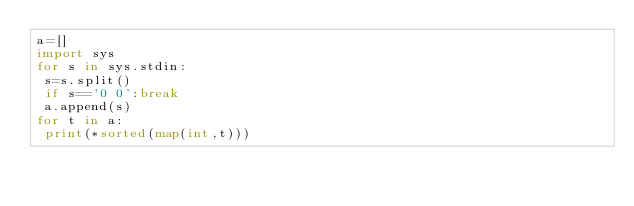<code> <loc_0><loc_0><loc_500><loc_500><_Python_>a=[]
import sys
for s in sys.stdin:
 s=s.split()
 if s=='0 0':break
 a.append(s)
for t in a:
 print(*sorted(map(int,t)))</code> 